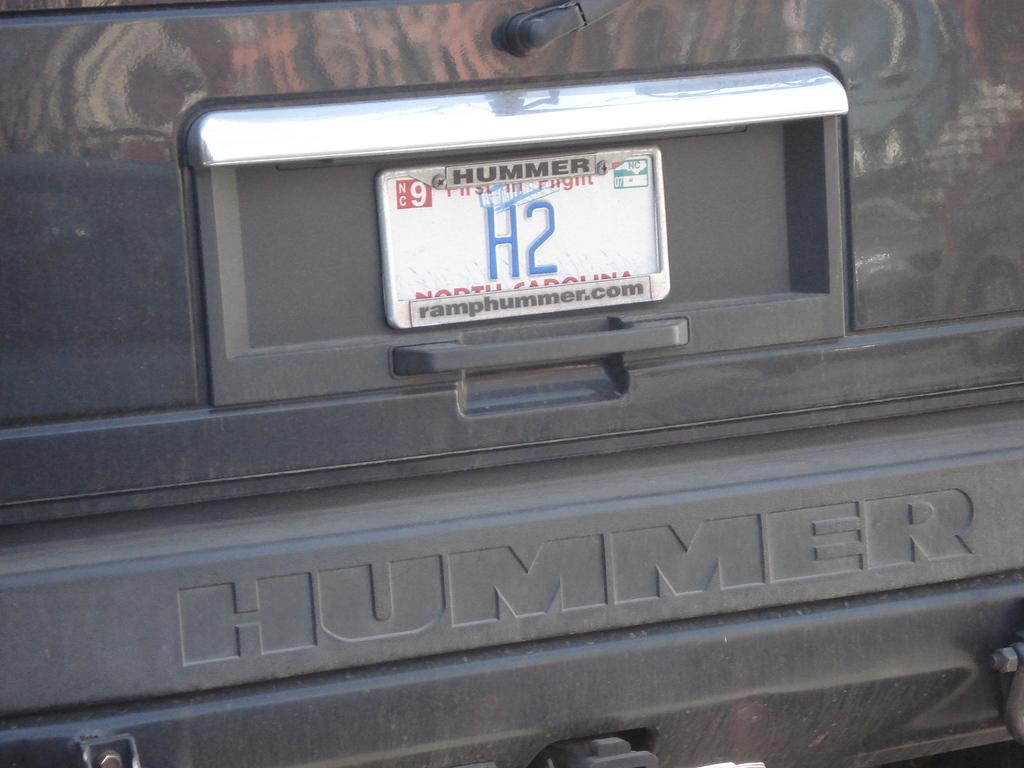<image>
Create a compact narrative representing the image presented. A North Carolina license plate on a Hummer. 